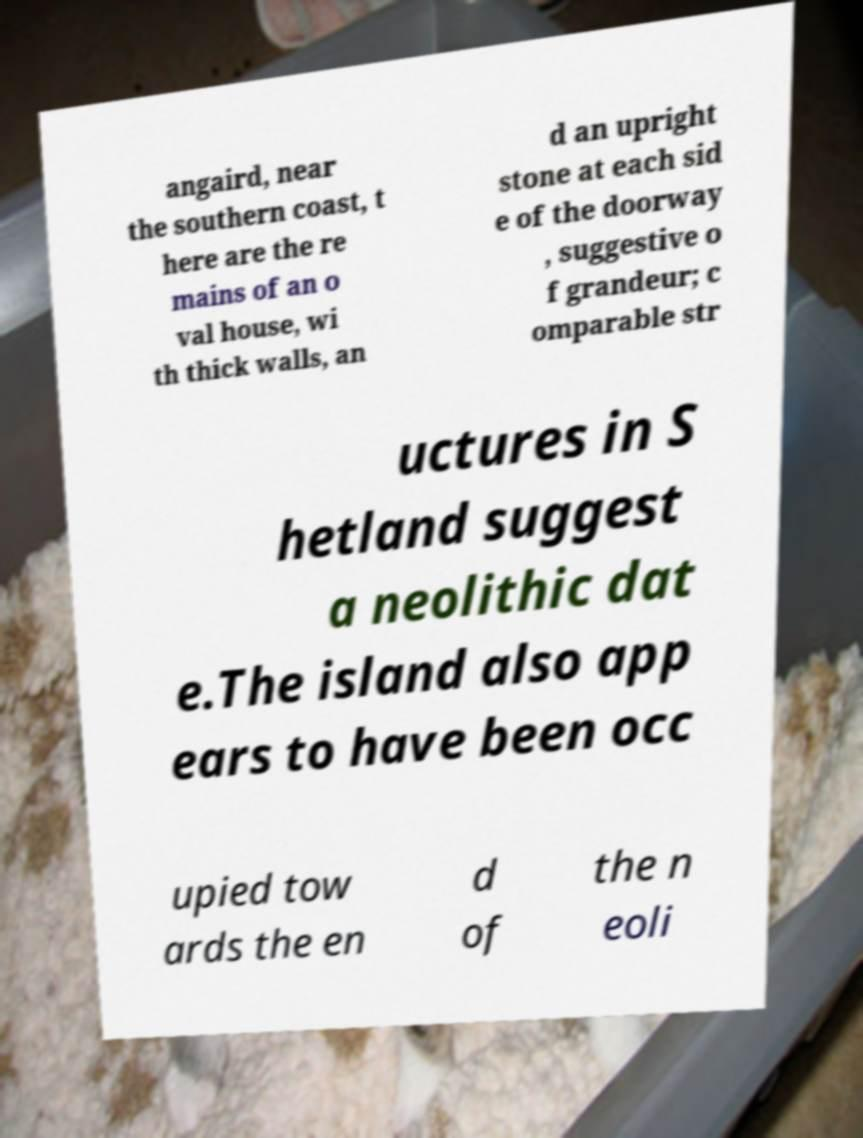Can you read and provide the text displayed in the image?This photo seems to have some interesting text. Can you extract and type it out for me? angaird, near the southern coast, t here are the re mains of an o val house, wi th thick walls, an d an upright stone at each sid e of the doorway , suggestive o f grandeur; c omparable str uctures in S hetland suggest a neolithic dat e.The island also app ears to have been occ upied tow ards the en d of the n eoli 